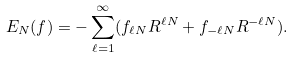<formula> <loc_0><loc_0><loc_500><loc_500>E _ { N } ( f ) = - \sum _ { \ell = 1 } ^ { \infty } ( f _ { \ell N } R ^ { \ell N } + f _ { - \ell N } R ^ { - \ell N } ) .</formula> 